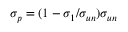Convert formula to latex. <formula><loc_0><loc_0><loc_500><loc_500>\sigma _ { p } = ( 1 - \sigma _ { 1 } / \sigma _ { u n } ) \sigma _ { u n }</formula> 